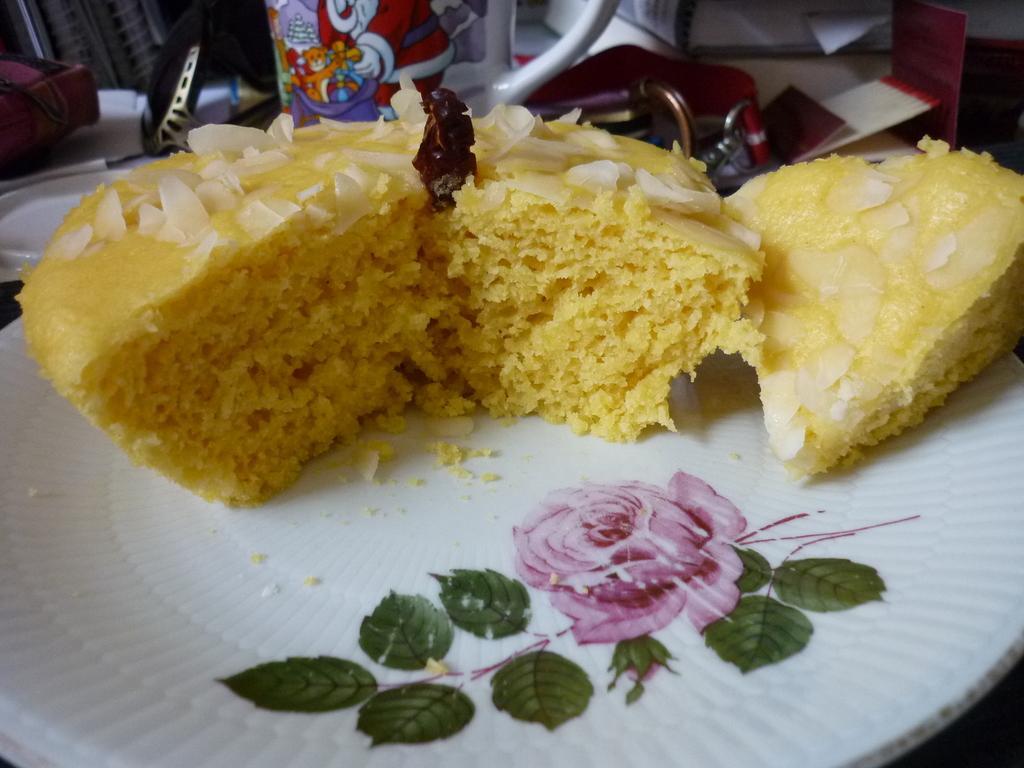In one or two sentences, can you explain what this image depicts? In this image I can see a white colored plate and on the plate I can see a food item which is yellow, white and brown in color and a design of a pink colored flower and few leaves which are green in color. In the background I can see another plate, a cup and few other objects. 